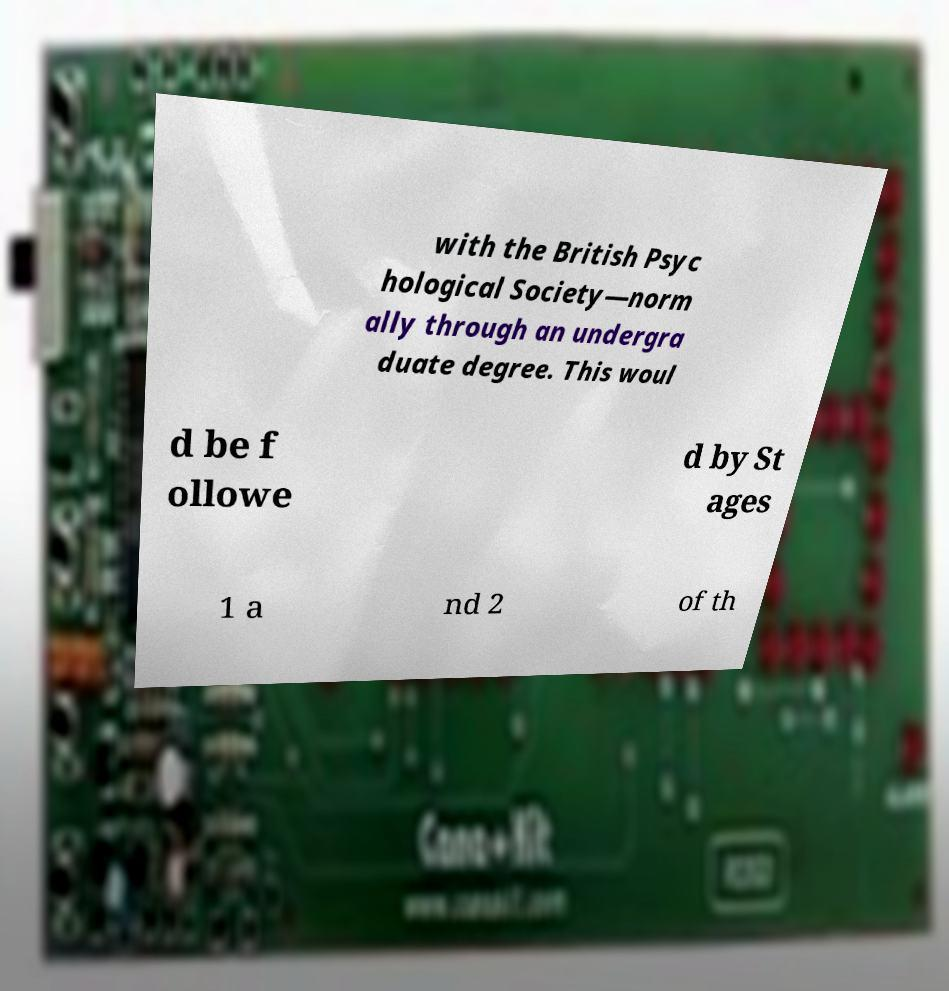I need the written content from this picture converted into text. Can you do that? with the British Psyc hological Society—norm ally through an undergra duate degree. This woul d be f ollowe d by St ages 1 a nd 2 of th 